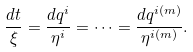Convert formula to latex. <formula><loc_0><loc_0><loc_500><loc_500>\frac { d t } { \xi } = \frac { d q ^ { i } } { \eta ^ { i } } = \dots = \frac { d q ^ { i ( m ) } } { \eta ^ { i ( m ) } } .</formula> 